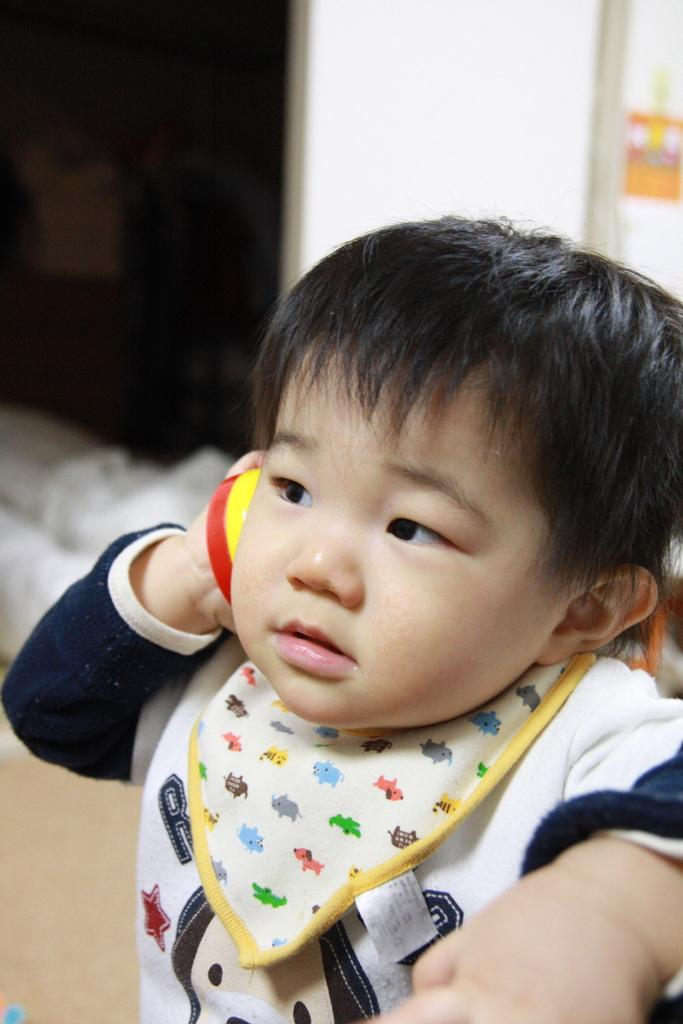What is the main subject of the image? The main subject of the image is a kid. What is the kid holding in the image? The kid is holding a red and yellow color object. What can be seen in the background of the image? There is a white color wall in the background of the image. What type of rifle is the kid using in the image? There is no rifle present in the image; the kid is holding a red and yellow color object. 